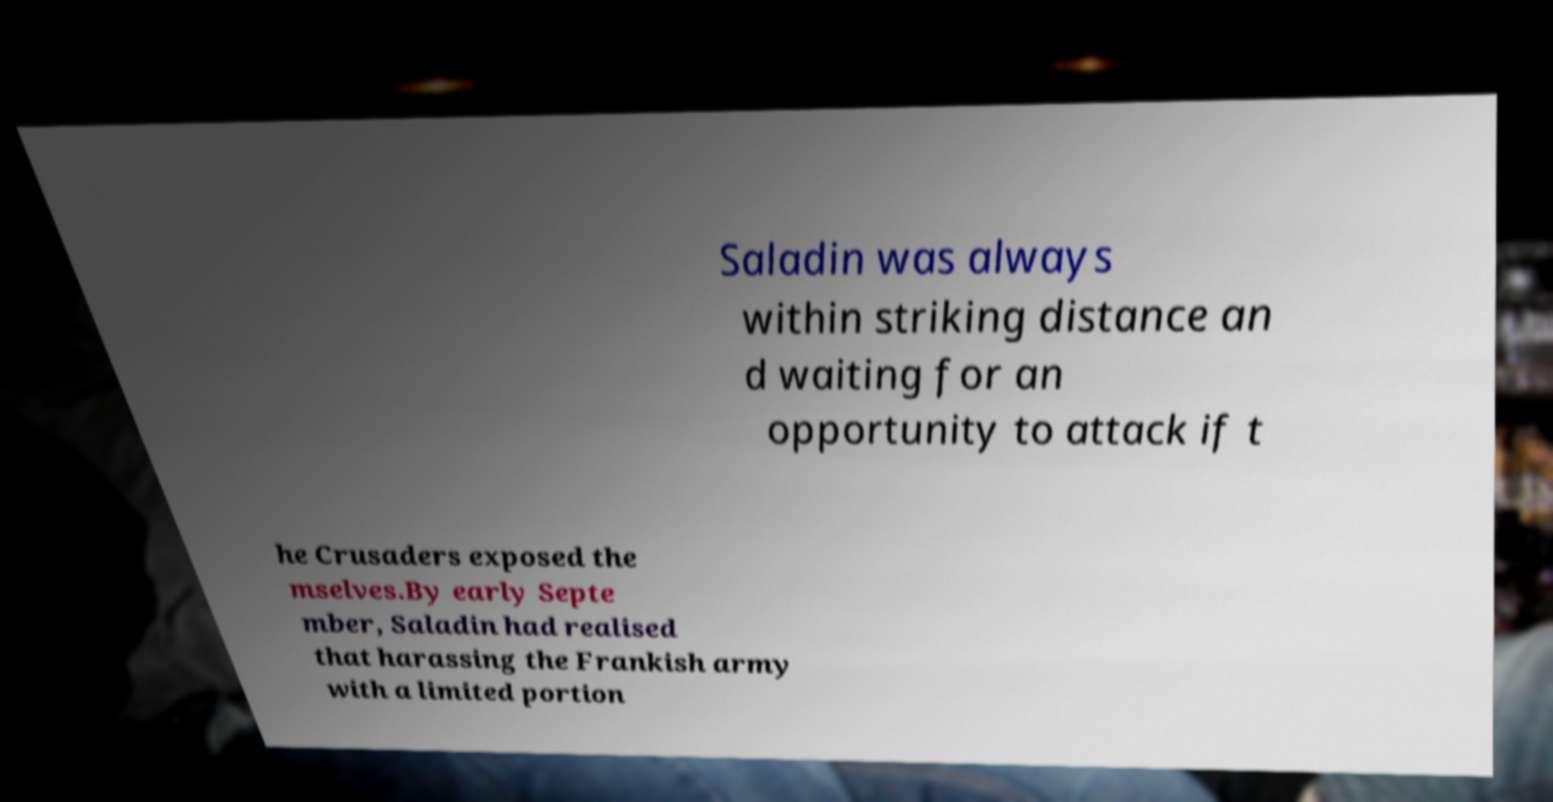Please read and relay the text visible in this image. What does it say? Saladin was always within striking distance an d waiting for an opportunity to attack if t he Crusaders exposed the mselves.By early Septe mber, Saladin had realised that harassing the Frankish army with a limited portion 